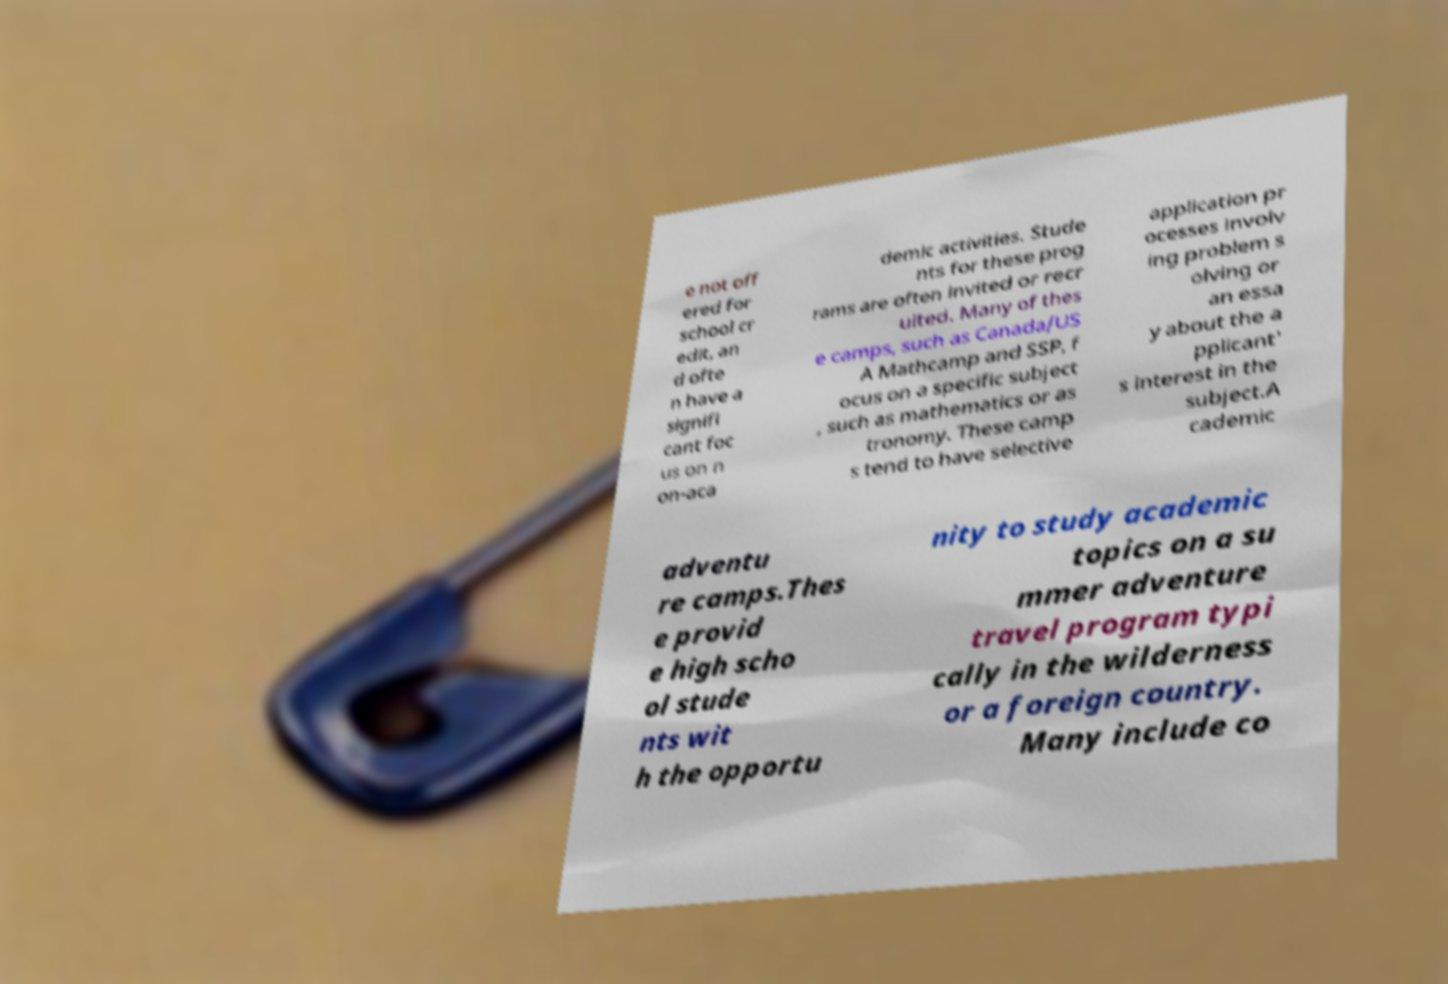Can you read and provide the text displayed in the image?This photo seems to have some interesting text. Can you extract and type it out for me? e not off ered for school cr edit, an d ofte n have a signifi cant foc us on n on-aca demic activities. Stude nts for these prog rams are often invited or recr uited. Many of thes e camps, such as Canada/US A Mathcamp and SSP, f ocus on a specific subject , such as mathematics or as tronomy. These camp s tend to have selective application pr ocesses involv ing problem s olving or an essa y about the a pplicant' s interest in the subject.A cademic adventu re camps.Thes e provid e high scho ol stude nts wit h the opportu nity to study academic topics on a su mmer adventure travel program typi cally in the wilderness or a foreign country. Many include co 